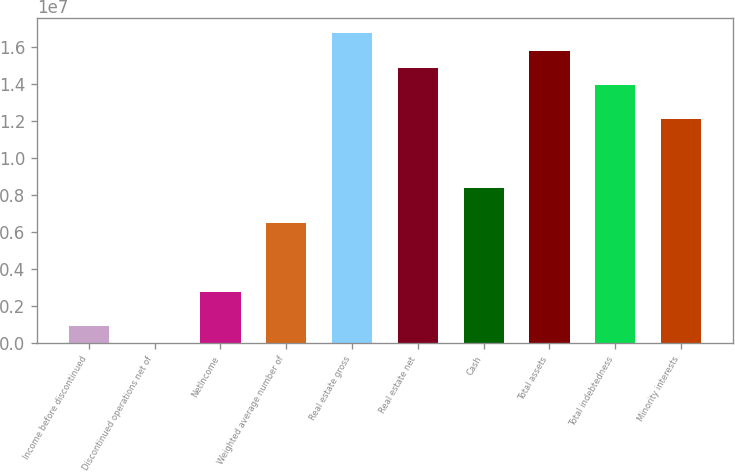Convert chart. <chart><loc_0><loc_0><loc_500><loc_500><bar_chart><fcel>Income before discontinued<fcel>Discontinued operations net of<fcel>NetIncome<fcel>Weighted average number of<fcel>Real estate gross<fcel>Real estate net<fcel>Cash<fcel>Total assets<fcel>Total indebtedness<fcel>Minority interests<nl><fcel>929123<fcel>0.26<fcel>2.78737e+06<fcel>6.50386e+06<fcel>1.67242e+07<fcel>1.4866e+07<fcel>8.3621e+06<fcel>1.57951e+07<fcel>1.39368e+07<fcel>1.20786e+07<nl></chart> 